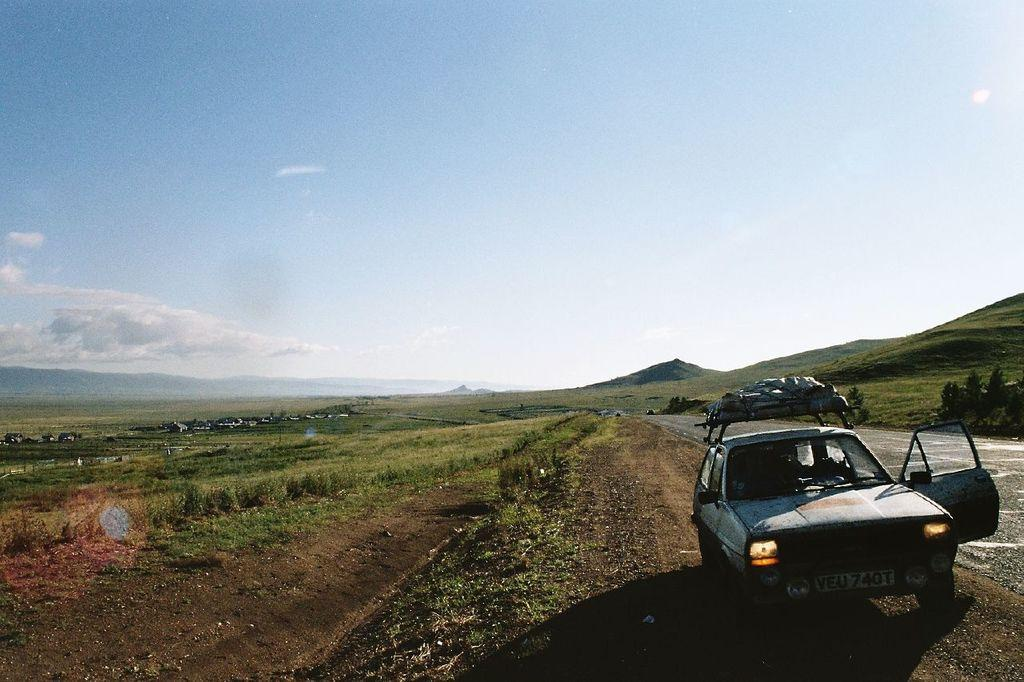What is the main subject of the image? There is a car in the image. What other natural elements can be seen in the image? There are plants, grass, trees, and hills visible in the image. Are there any man-made structures in the image? Yes, there are houses in the image. What is visible in the background of the image? The sky is visible in the background of the image. Can you see the ocean in the image? No, the ocean is not present in the image. What type of patch is being used to cover the car's windshield? There is no patch visible on the car's windshield in the image. 